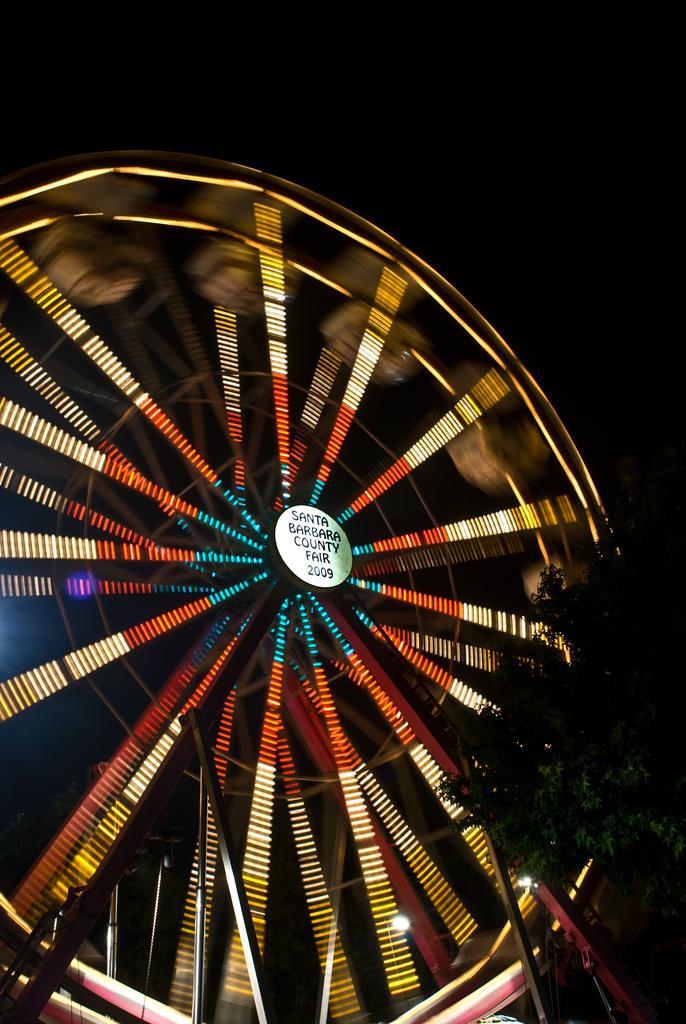How would you summarize this image in a sentence or two? In the center of the image, we can see a giant wheel with light and there is a board and on the right, we can see a tree. 